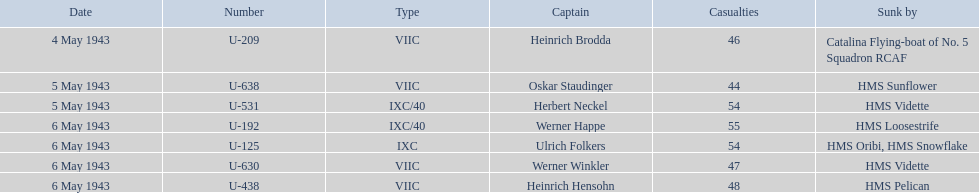Who were the u-boat commanders? Heinrich Brodda, Oskar Staudinger, Herbert Neckel, Werner Happe, Ulrich Folkers, Werner Winkler, Heinrich Hensohn. What dates did the u-boat captains go missing? 4 May 1943, 5 May 1943, 5 May 1943, 6 May 1943, 6 May 1943, 6 May 1943, 6 May 1943. Among them, which ones disappeared on may 5th? Oskar Staudinger, Herbert Neckel. Besides oskar staudinger, who else went missing on that day? Herbert Neckel. 